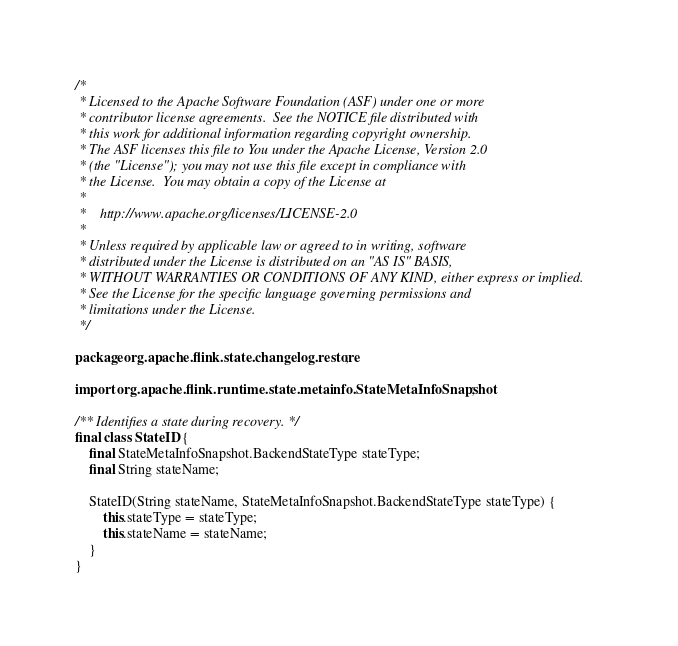<code> <loc_0><loc_0><loc_500><loc_500><_Java_>/*
 * Licensed to the Apache Software Foundation (ASF) under one or more
 * contributor license agreements.  See the NOTICE file distributed with
 * this work for additional information regarding copyright ownership.
 * The ASF licenses this file to You under the Apache License, Version 2.0
 * (the "License"); you may not use this file except in compliance with
 * the License.  You may obtain a copy of the License at
 *
 *    http://www.apache.org/licenses/LICENSE-2.0
 *
 * Unless required by applicable law or agreed to in writing, software
 * distributed under the License is distributed on an "AS IS" BASIS,
 * WITHOUT WARRANTIES OR CONDITIONS OF ANY KIND, either express or implied.
 * See the License for the specific language governing permissions and
 * limitations under the License.
 */

package org.apache.flink.state.changelog.restore;

import org.apache.flink.runtime.state.metainfo.StateMetaInfoSnapshot;

/** Identifies a state during recovery. */
final class StateID {
    final StateMetaInfoSnapshot.BackendStateType stateType;
    final String stateName;

    StateID(String stateName, StateMetaInfoSnapshot.BackendStateType stateType) {
        this.stateType = stateType;
        this.stateName = stateName;
    }
}
</code> 